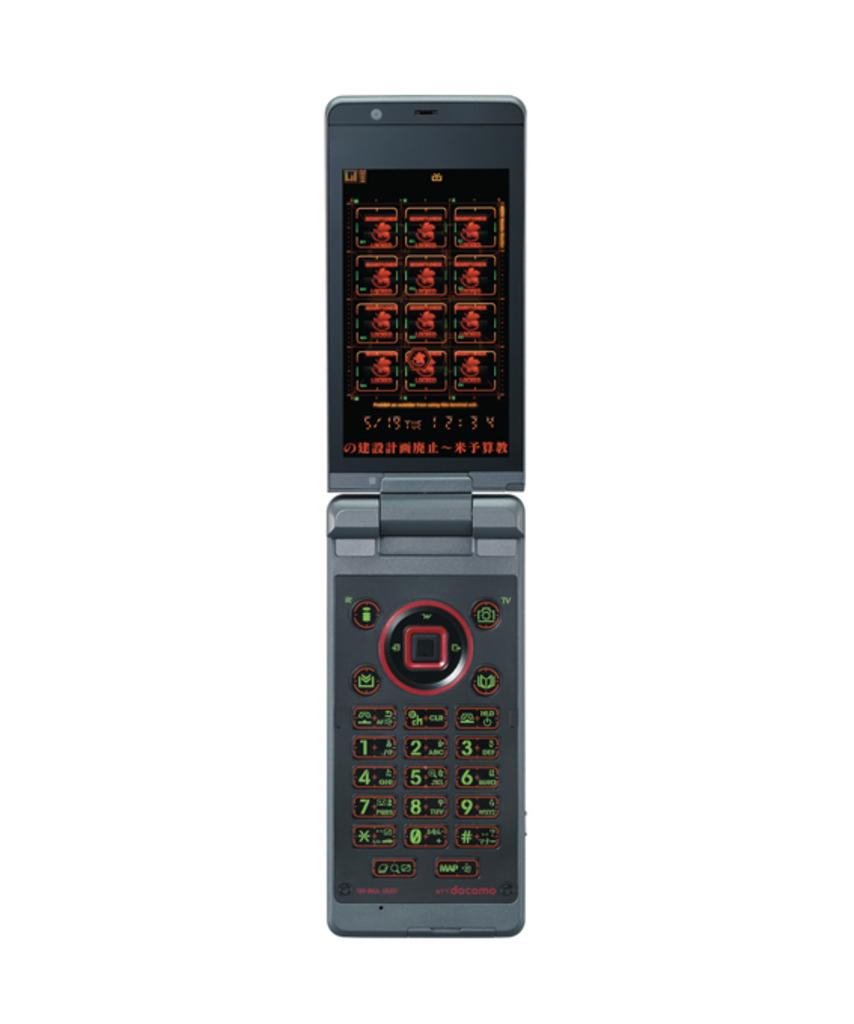Provide a one-sentence caption for the provided image. The dial pad of a weird flip phone has a button labelled TV in the top right. 